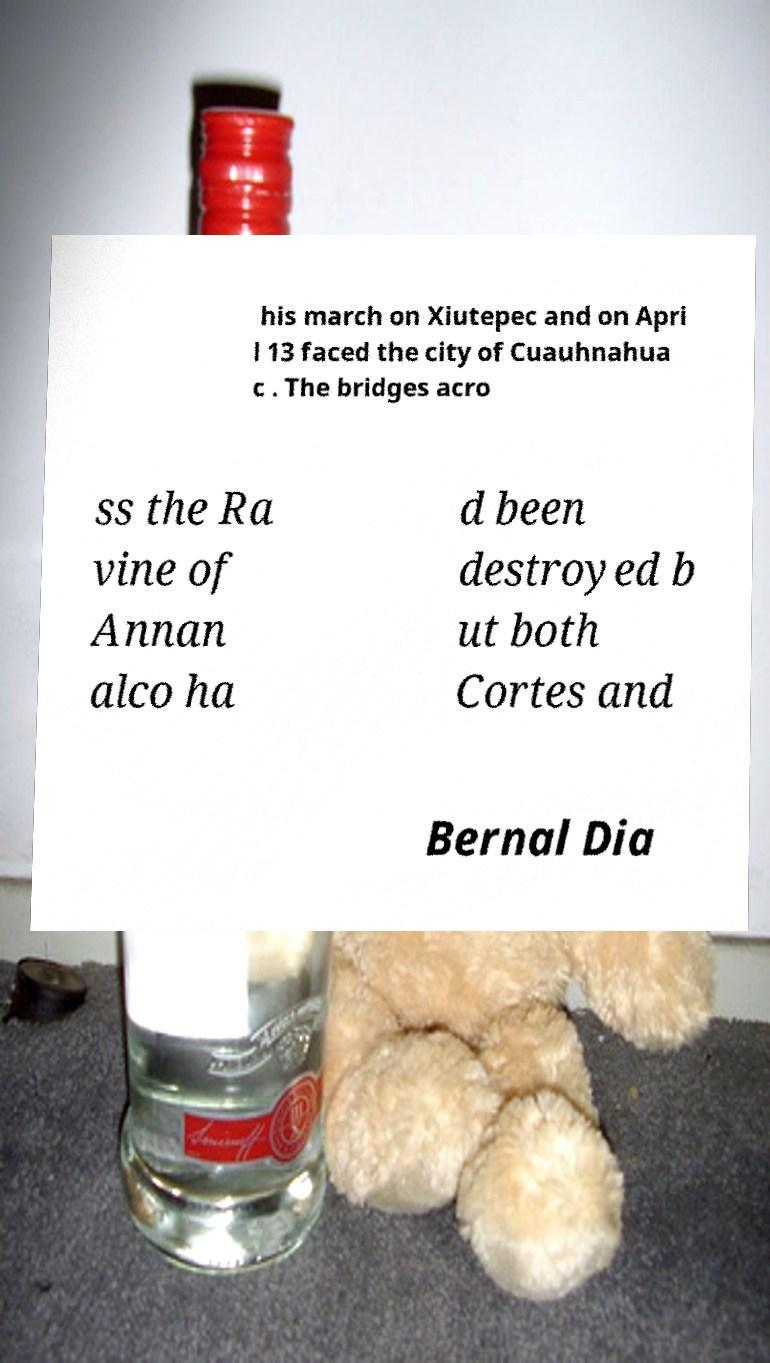Can you read and provide the text displayed in the image?This photo seems to have some interesting text. Can you extract and type it out for me? his march on Xiutepec and on Apri l 13 faced the city of Cuauhnahua c . The bridges acro ss the Ra vine of Annan alco ha d been destroyed b ut both Cortes and Bernal Dia 